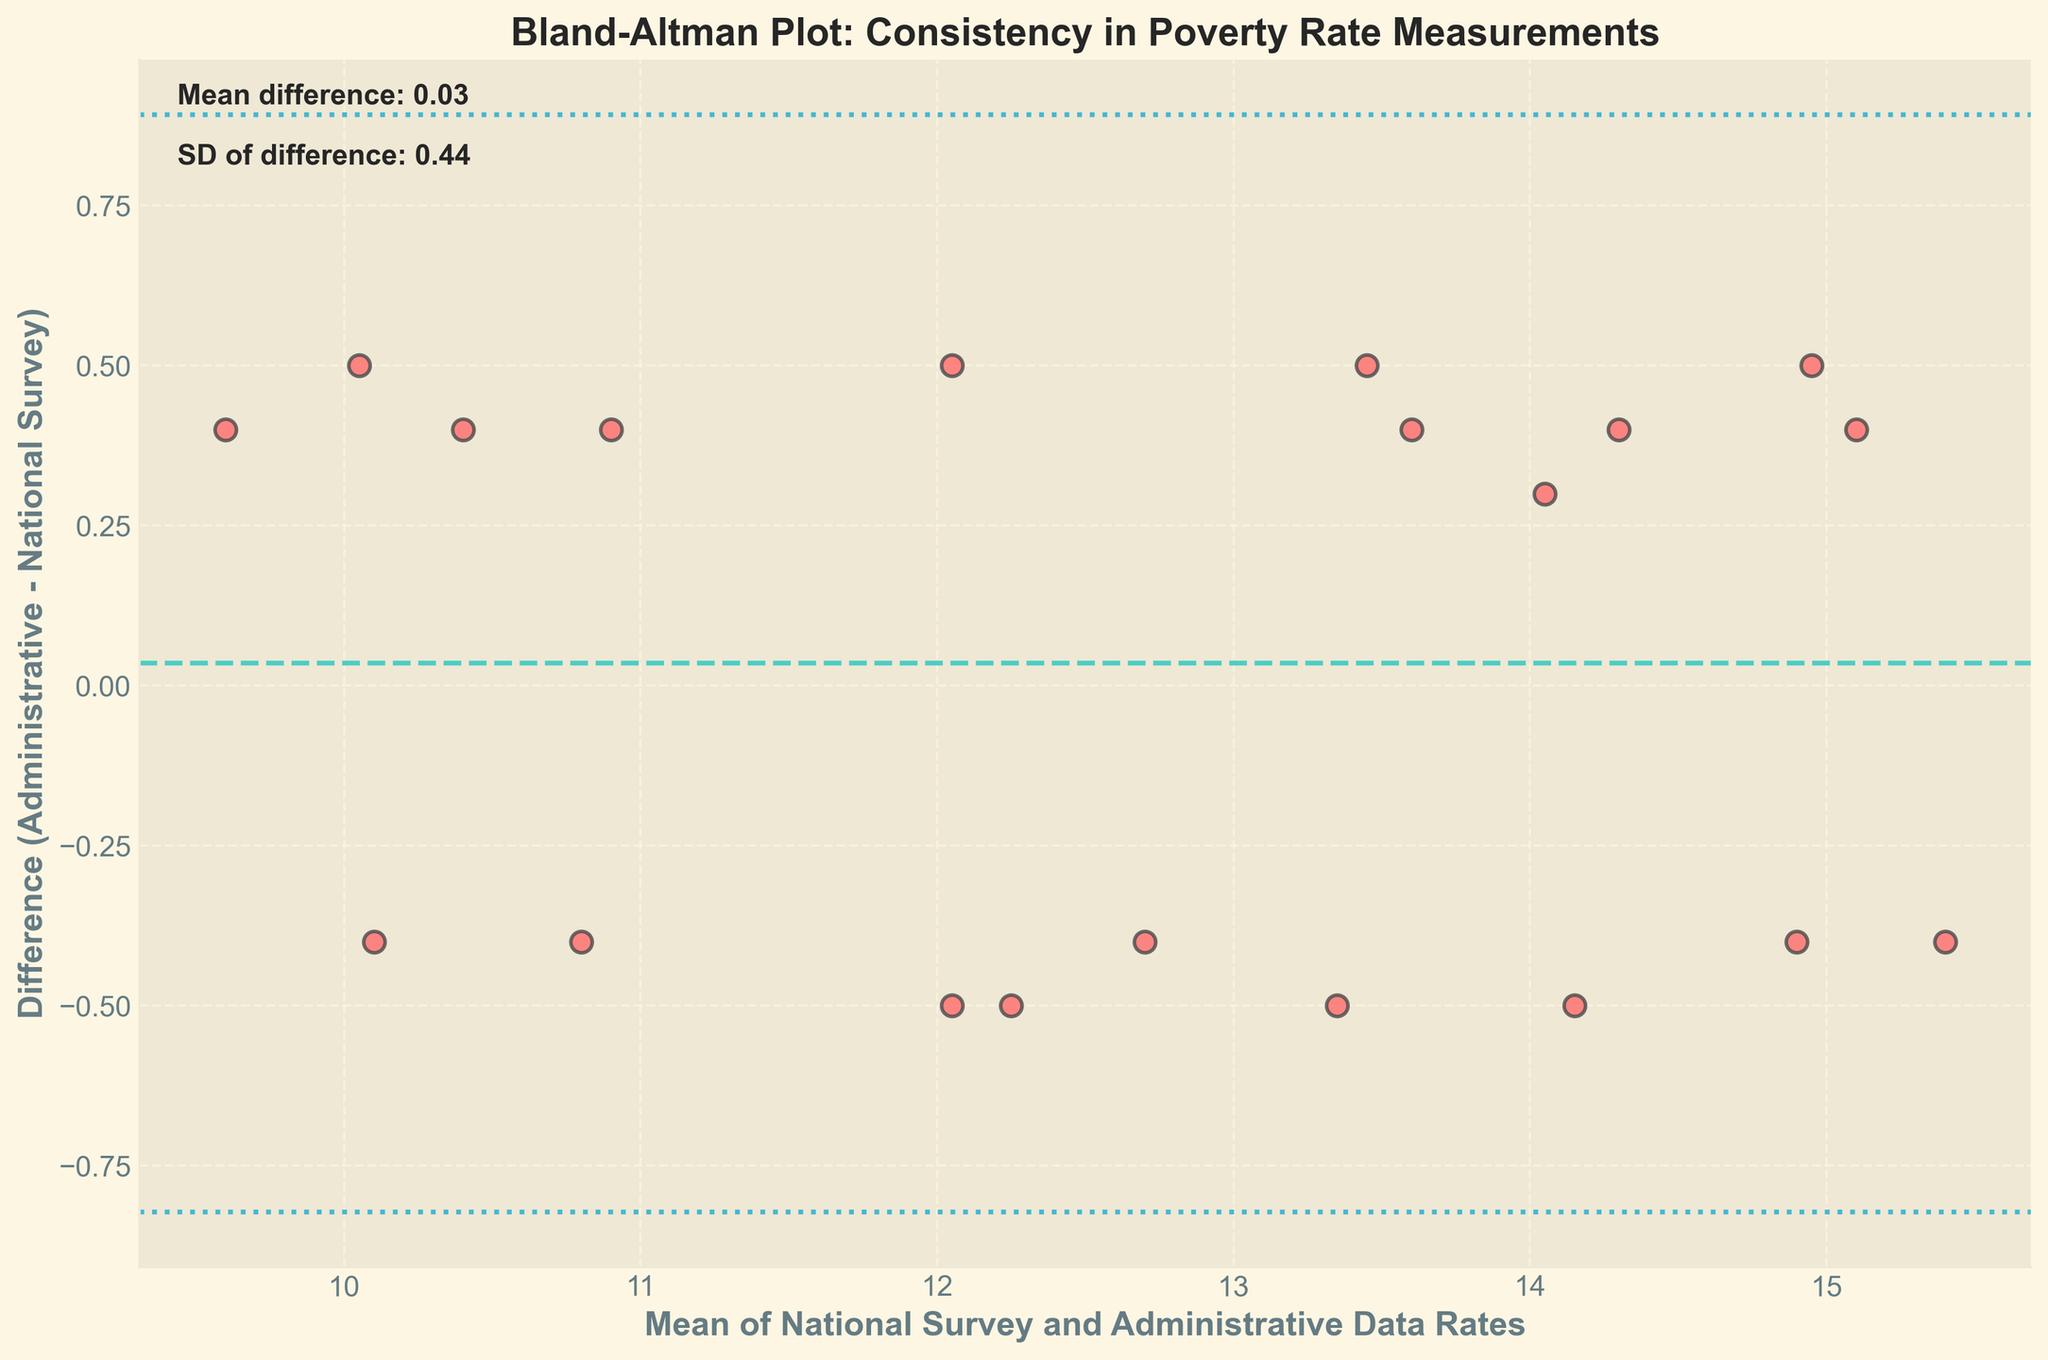What is the mean difference between the administrative data and the national survey rate? To find the mean difference, look at the plotted horizontal dashed line which represents the average of the differences between the administrative data and the national survey rates. The text annotation on the plot specifies this value.
Answer: -0.10 What is the standard deviation of the differences between the administrative data and the national survey rate? The standard deviation of the differences is given in the text annotation on the plot. It quantifies the amount of variation in the differences.
Answer: 0.39 Which state has the highest mean poverty rate between the national survey and administrative data? To find the state with the highest mean poverty rate, look for the data point that is furthest to the right on the x-axis, which represents the mean of the national survey and administrative data rates.
Answer: Arizona How many data points fall outside the 95% limits of agreement? The 95% limits of agreement are marked by the horizontal dashed lines at mean difference ± 1.96 times the standard deviation. Count the points that lie outside these limits.
Answer: 1 Is the difference between the administrative data and the national survey rate more consistent at lower or higher mean rates? To determine consistency, examine the spread of the data points along the y-axis across different x-axis values. A tighter spread indicates more consistency.
Answer: Lower mean rates Which state has the largest positive difference between the administrative data and the national survey rate? To find this, look for the highest point on the y-axis, as this represents the largest positive difference.
Answer: Tennessee Are there more data points above or below the mean difference line? Count the number of points that lie above and below the horizontal mean difference line. This helps to understand the symmetry of the differences.
Answer: Above Which state has a negative difference, implying the national survey rate is higher than the administrative data rate? Identify the data points located below the zero line on the y-axis, then determine the corresponding state(s) based on their position.
Answer: Multiple states, example: Georgia What is indicated by the 95% limits of agreement in the Bland-Altman plot? The 95% limits of agreement indicate the range within which 95% of differences between the two measurement methods are expected to lie, helping to assess the consistency between them.
Answer: Range of consistency 